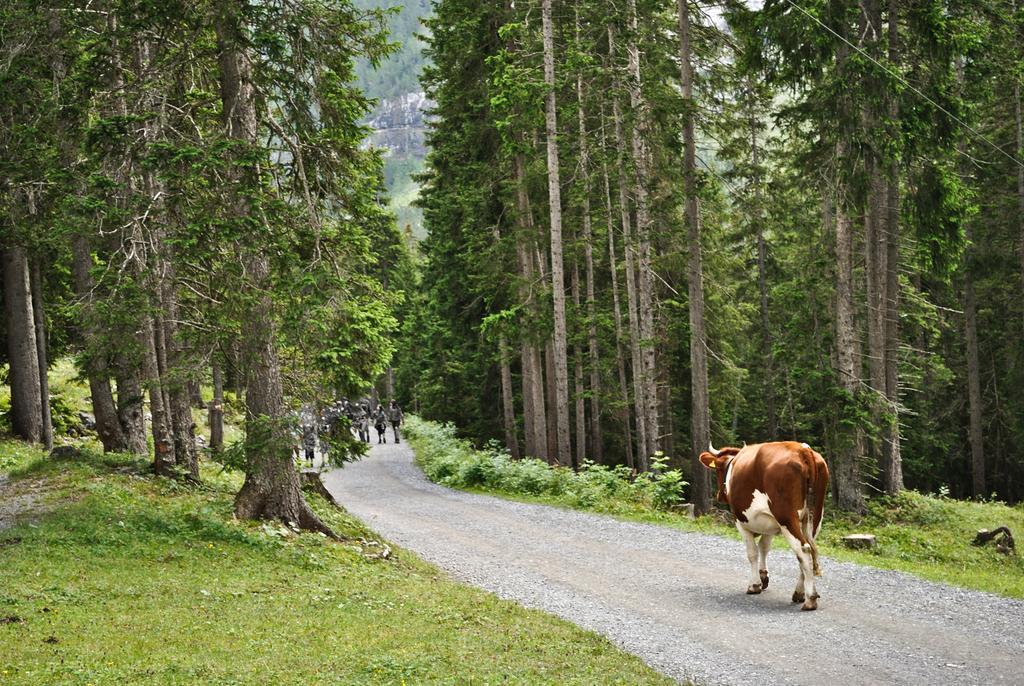How would you summarize this image in a sentence or two? In this picture we can see a cow and some people walking on the road surrounded with trees and grass on either side. 